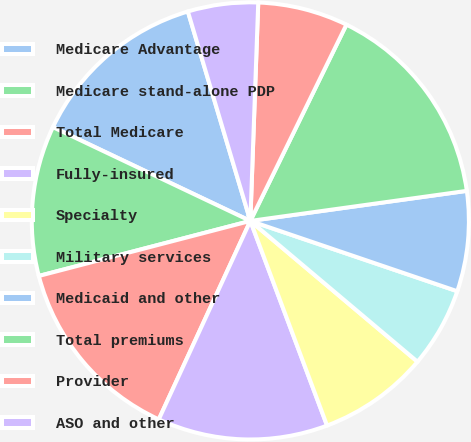<chart> <loc_0><loc_0><loc_500><loc_500><pie_chart><fcel>Medicare Advantage<fcel>Medicare stand-alone PDP<fcel>Total Medicare<fcel>Fully-insured<fcel>Specialty<fcel>Military services<fcel>Medicaid and other<fcel>Total premiums<fcel>Provider<fcel>ASO and other<nl><fcel>13.33%<fcel>11.11%<fcel>14.07%<fcel>12.59%<fcel>8.15%<fcel>5.93%<fcel>7.41%<fcel>15.56%<fcel>6.67%<fcel>5.19%<nl></chart> 